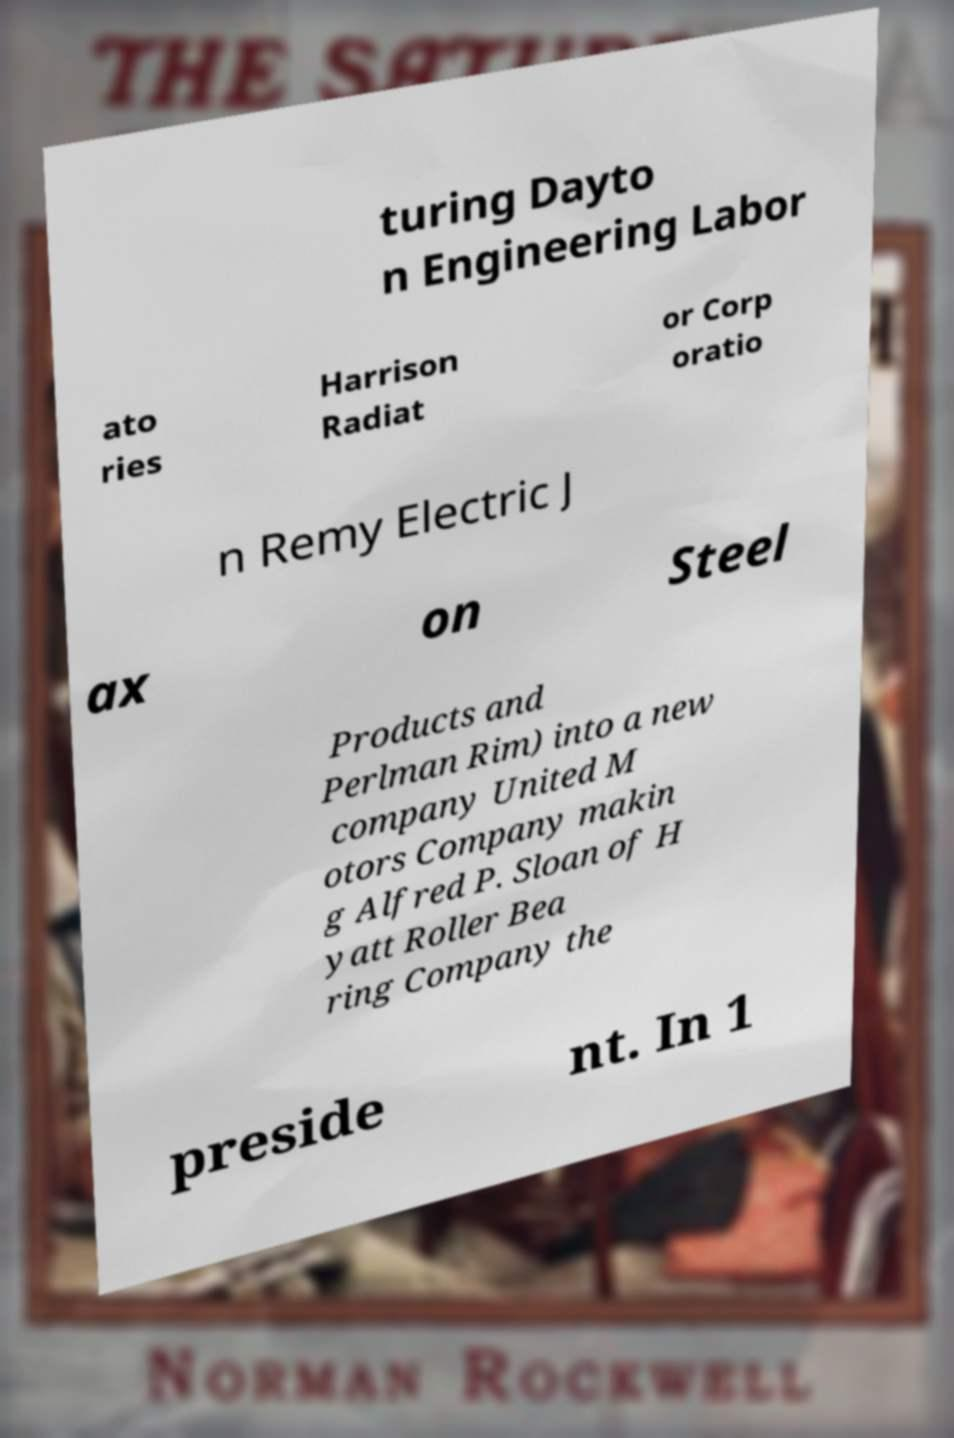Please read and relay the text visible in this image. What does it say? turing Dayto n Engineering Labor ato ries Harrison Radiat or Corp oratio n Remy Electric J ax on Steel Products and Perlman Rim) into a new company United M otors Company makin g Alfred P. Sloan of H yatt Roller Bea ring Company the preside nt. In 1 